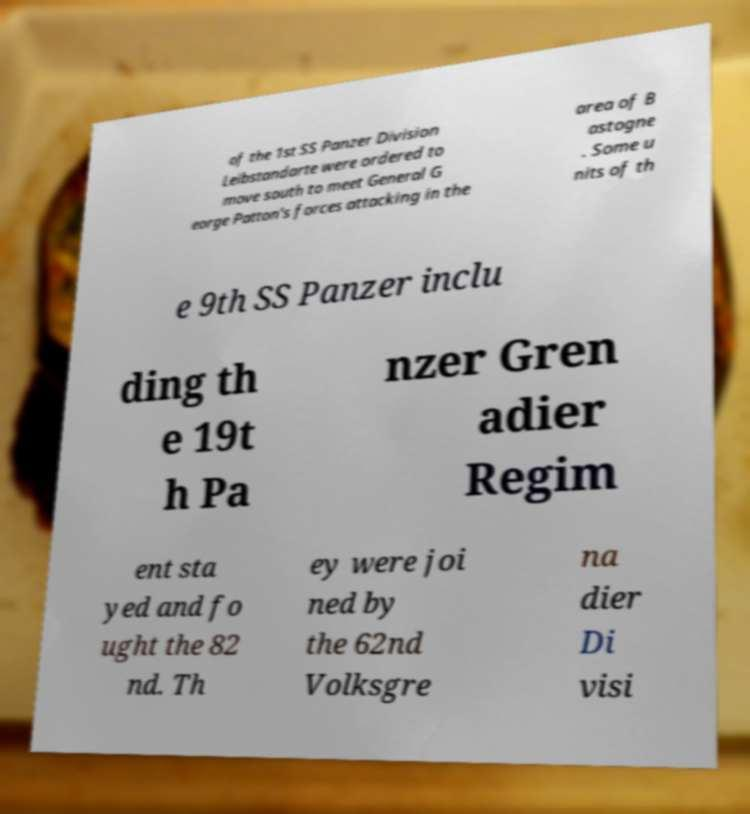There's text embedded in this image that I need extracted. Can you transcribe it verbatim? of the 1st SS Panzer Division Leibstandarte were ordered to move south to meet General G eorge Patton's forces attacking in the area of B astogne . Some u nits of th e 9th SS Panzer inclu ding th e 19t h Pa nzer Gren adier Regim ent sta yed and fo ught the 82 nd. Th ey were joi ned by the 62nd Volksgre na dier Di visi 